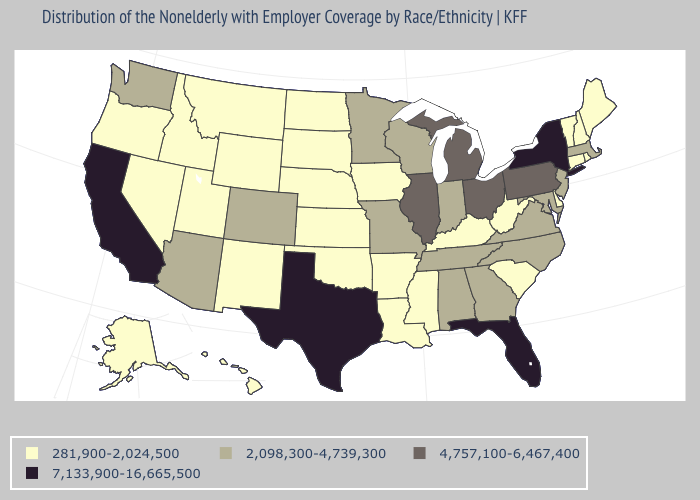Which states have the lowest value in the MidWest?
Write a very short answer. Iowa, Kansas, Nebraska, North Dakota, South Dakota. What is the value of New Hampshire?
Keep it brief. 281,900-2,024,500. Is the legend a continuous bar?
Concise answer only. No. Does Texas have the highest value in the USA?
Keep it brief. Yes. Name the states that have a value in the range 7,133,900-16,665,500?
Write a very short answer. California, Florida, New York, Texas. What is the lowest value in states that border Colorado?
Keep it brief. 281,900-2,024,500. Does New Hampshire have the highest value in the Northeast?
Write a very short answer. No. Name the states that have a value in the range 4,757,100-6,467,400?
Short answer required. Illinois, Michigan, Ohio, Pennsylvania. Name the states that have a value in the range 4,757,100-6,467,400?
Be succinct. Illinois, Michigan, Ohio, Pennsylvania. Which states have the lowest value in the USA?
Be succinct. Alaska, Arkansas, Connecticut, Delaware, Hawaii, Idaho, Iowa, Kansas, Kentucky, Louisiana, Maine, Mississippi, Montana, Nebraska, Nevada, New Hampshire, New Mexico, North Dakota, Oklahoma, Oregon, Rhode Island, South Carolina, South Dakota, Utah, Vermont, West Virginia, Wyoming. Among the states that border Oklahoma , does Kansas have the highest value?
Write a very short answer. No. Among the states that border Nebraska , which have the lowest value?
Give a very brief answer. Iowa, Kansas, South Dakota, Wyoming. What is the value of Oregon?
Write a very short answer. 281,900-2,024,500. Does the first symbol in the legend represent the smallest category?
Write a very short answer. Yes. 